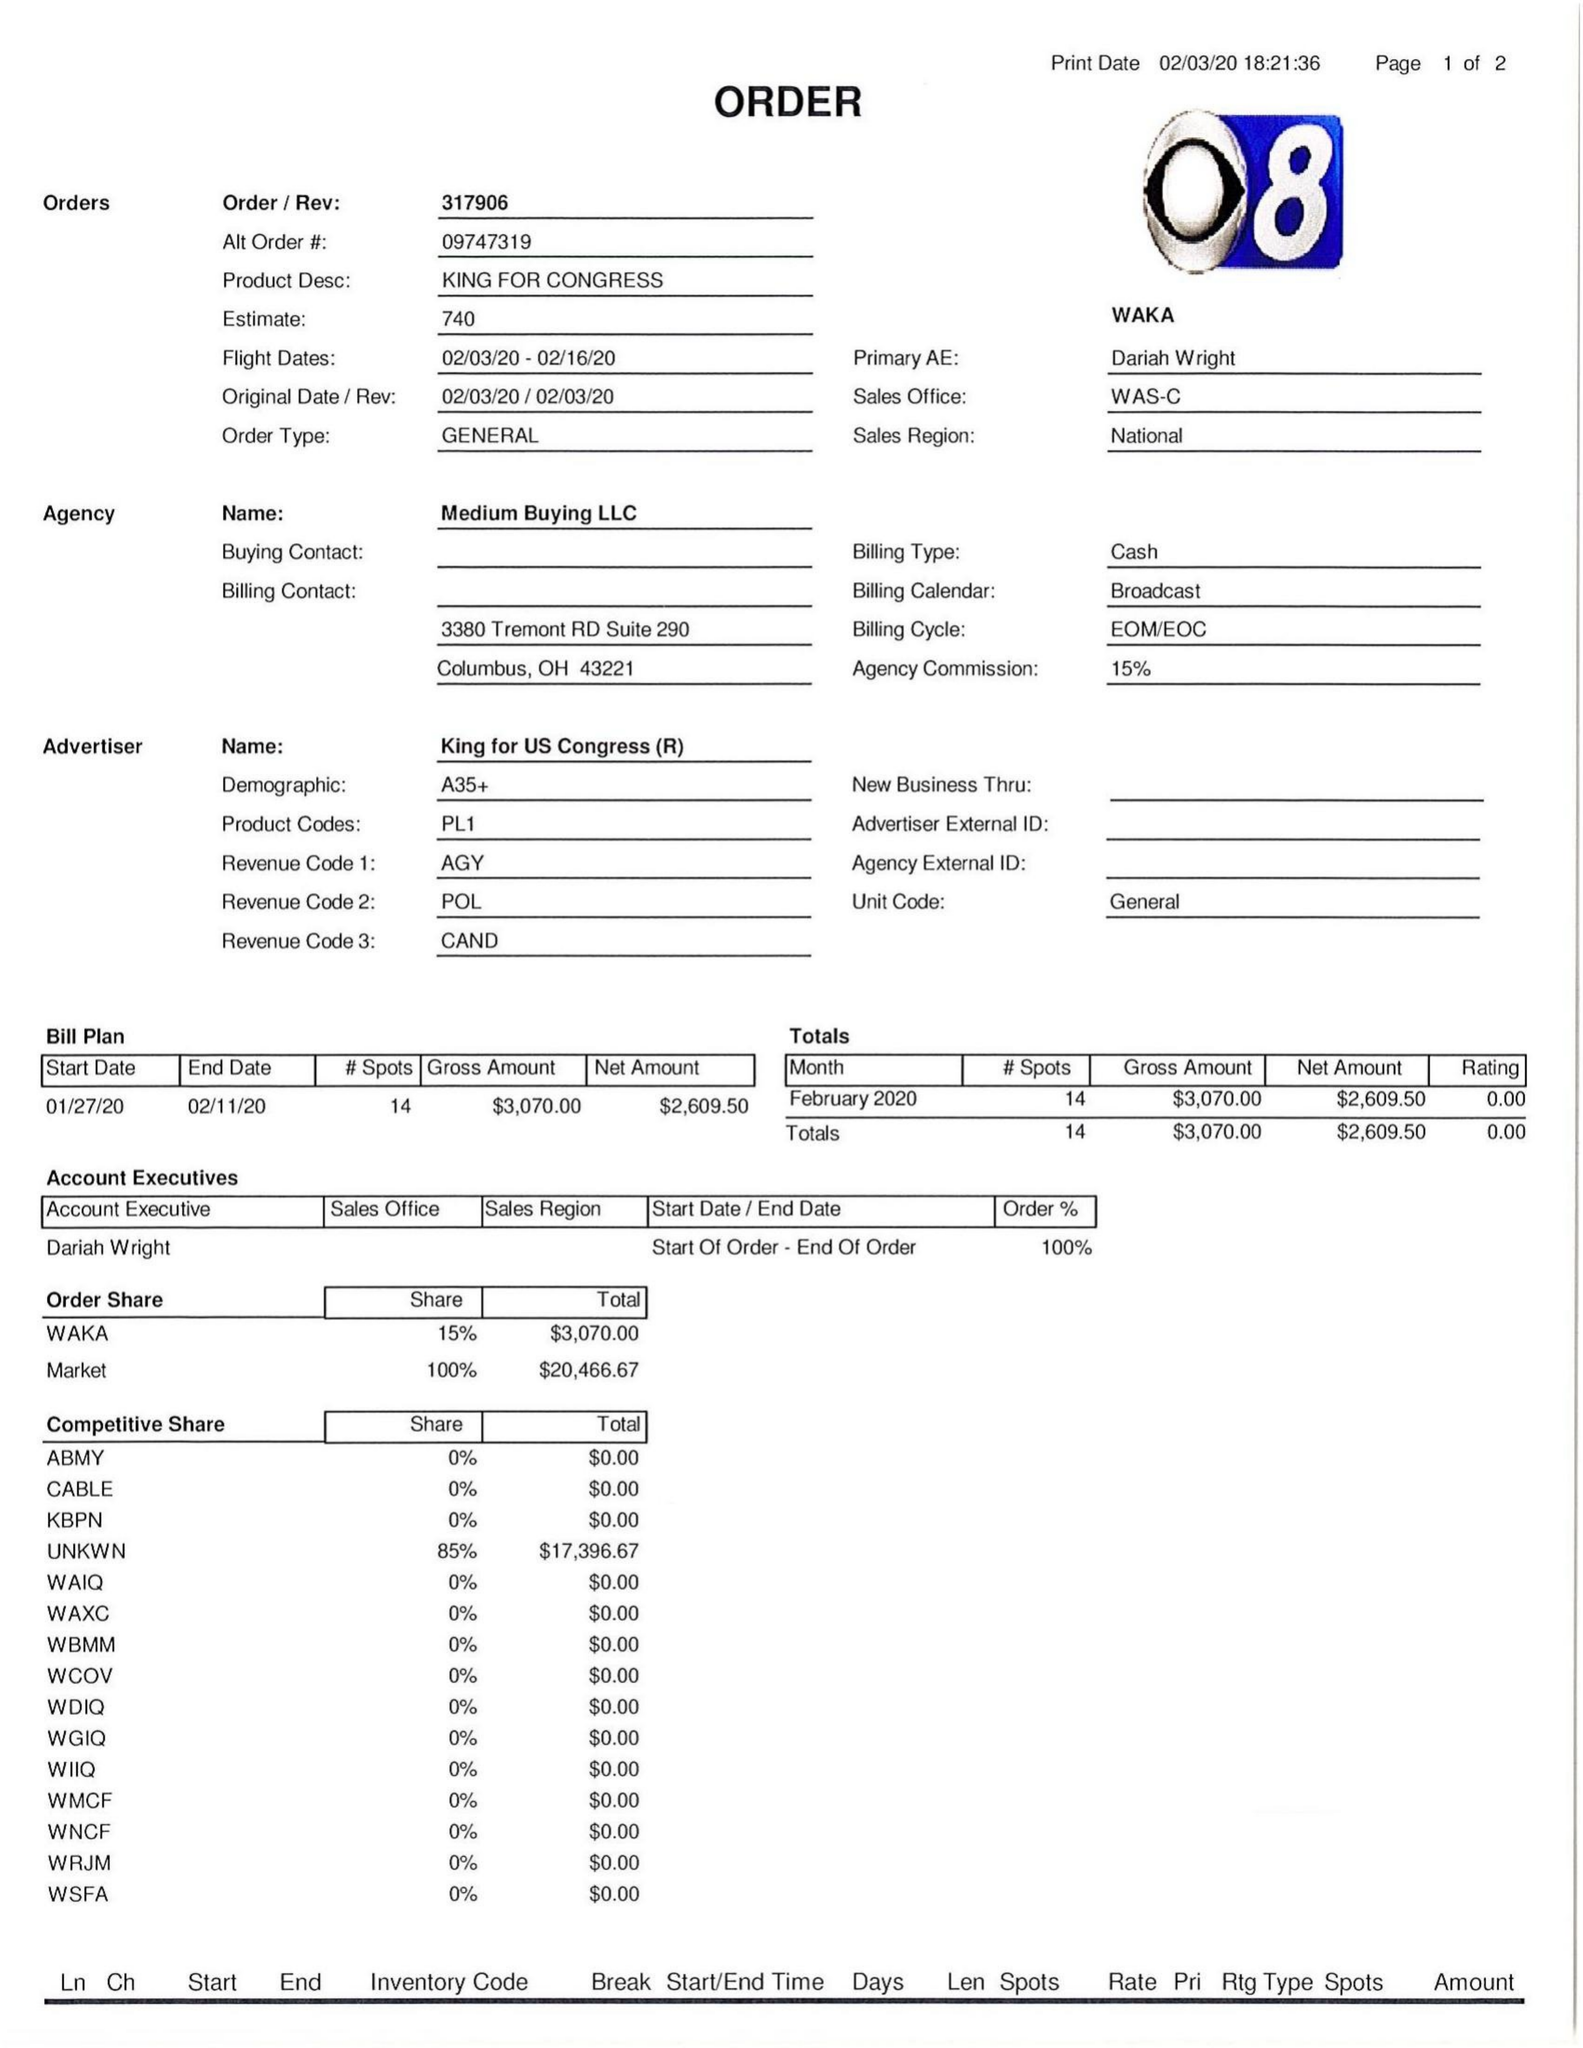What is the value for the advertiser?
Answer the question using a single word or phrase. KING FOR US CONGRESS (R) 